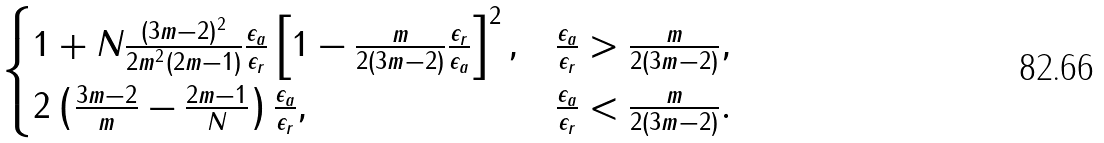Convert formula to latex. <formula><loc_0><loc_0><loc_500><loc_500>\begin{cases} 1 + N \frac { ( 3 m - 2 ) ^ { 2 } } { 2 m ^ { 2 } ( 2 m - 1 ) } \frac { \epsilon _ { a } } { \epsilon _ { r } } \left [ 1 - \frac { m } { 2 ( 3 m - 2 ) } \frac { \epsilon _ { r } } { \epsilon _ { a } } \right ] ^ { 2 } , & \frac { \epsilon _ { a } } { \epsilon _ { r } } > \frac { m } { 2 ( 3 m - 2 ) } , \\ 2 \left ( \frac { 3 m - 2 } { m } - \frac { 2 m - 1 } { N } \right ) \frac { \epsilon _ { a } } { \epsilon _ { r } } , & \frac { \epsilon _ { a } } { \epsilon _ { r } } < \frac { m } { 2 ( 3 m - 2 ) } . \end{cases}</formula> 